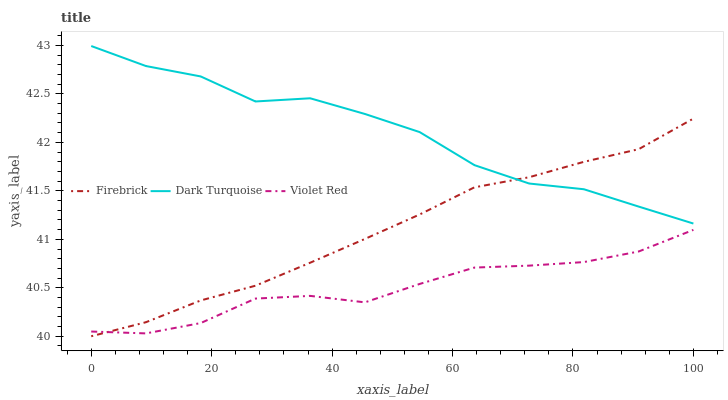Does Violet Red have the minimum area under the curve?
Answer yes or no. Yes. Does Dark Turquoise have the maximum area under the curve?
Answer yes or no. Yes. Does Firebrick have the minimum area under the curve?
Answer yes or no. No. Does Firebrick have the maximum area under the curve?
Answer yes or no. No. Is Firebrick the smoothest?
Answer yes or no. Yes. Is Dark Turquoise the roughest?
Answer yes or no. Yes. Is Violet Red the smoothest?
Answer yes or no. No. Is Violet Red the roughest?
Answer yes or no. No. Does Firebrick have the lowest value?
Answer yes or no. Yes. Does Violet Red have the lowest value?
Answer yes or no. No. Does Dark Turquoise have the highest value?
Answer yes or no. Yes. Does Firebrick have the highest value?
Answer yes or no. No. Is Violet Red less than Dark Turquoise?
Answer yes or no. Yes. Is Dark Turquoise greater than Violet Red?
Answer yes or no. Yes. Does Firebrick intersect Dark Turquoise?
Answer yes or no. Yes. Is Firebrick less than Dark Turquoise?
Answer yes or no. No. Is Firebrick greater than Dark Turquoise?
Answer yes or no. No. Does Violet Red intersect Dark Turquoise?
Answer yes or no. No. 